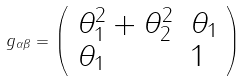Convert formula to latex. <formula><loc_0><loc_0><loc_500><loc_500>g _ { \alpha \beta } = \left ( \begin{array} { l l } \theta _ { 1 } ^ { 2 } + \theta _ { 2 } ^ { 2 } & \theta _ { 1 } \\ \theta _ { 1 } & 1 \end{array} \right )</formula> 